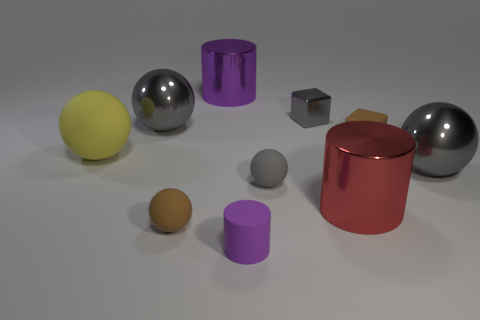Subtract all yellow cylinders. How many gray spheres are left? 3 Subtract all yellow spheres. How many spheres are left? 4 Subtract all cylinders. How many objects are left? 7 Add 2 tiny gray cubes. How many tiny gray cubes are left? 3 Add 6 small red matte things. How many small red matte things exist? 6 Subtract 1 brown blocks. How many objects are left? 9 Subtract all large yellow cylinders. Subtract all gray shiny blocks. How many objects are left? 9 